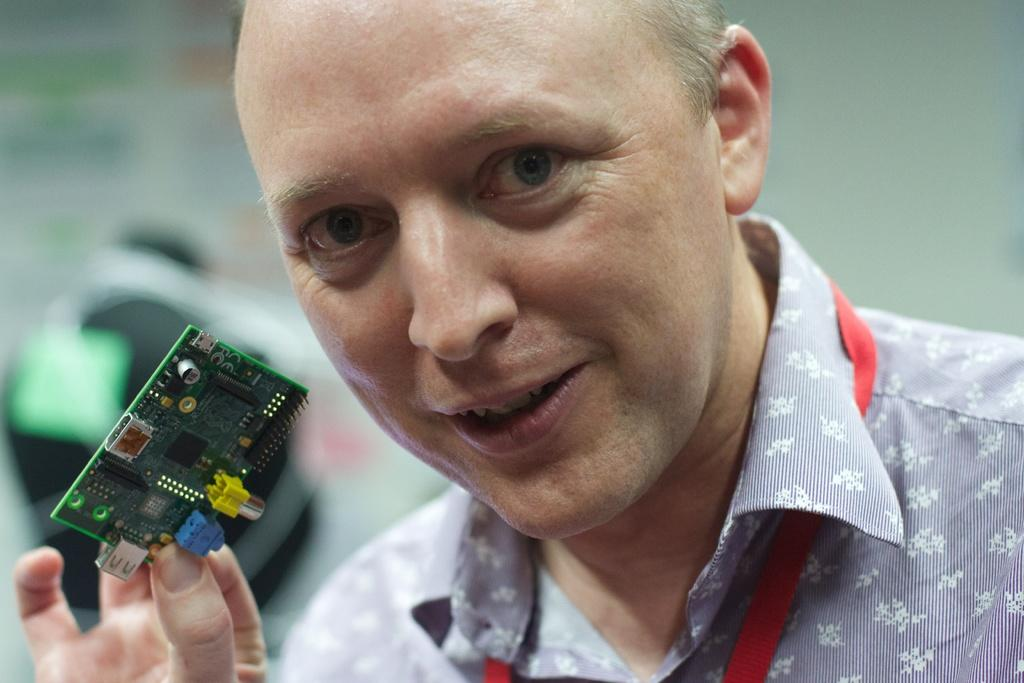What is the main subject of the image? There is a person in the image. What is the person holding in the image? The person is holding an integrated circuit. Can you describe the background of the image? The background of the image is blurry. What type of arithmetic problem is the person solving in the image? There is no arithmetic problem visible in the image; the person is holding an integrated circuit. What color is the box that the person is sitting on in the image? There is no box present in the image; the person is standing. 